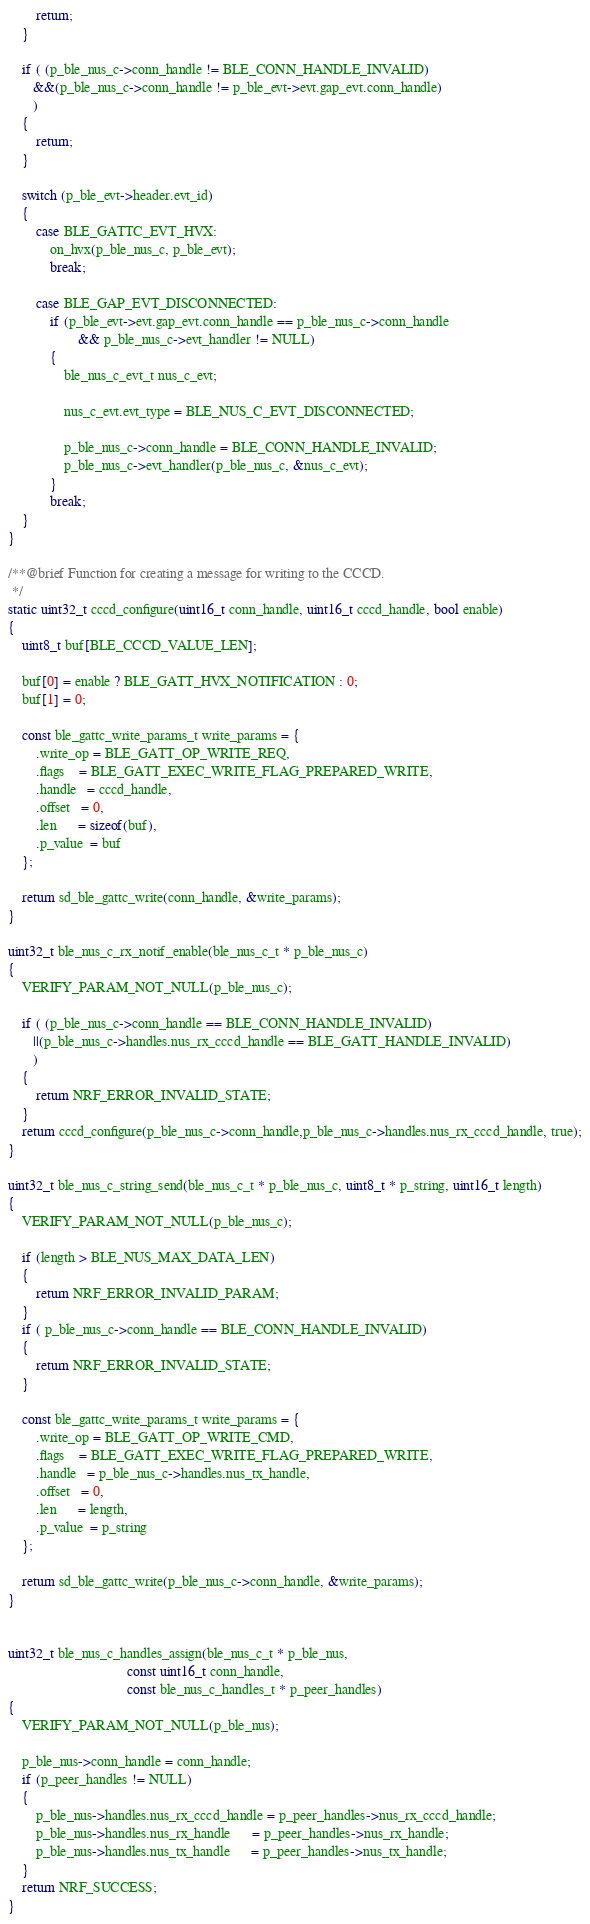<code> <loc_0><loc_0><loc_500><loc_500><_C_>        return;
    }

    if ( (p_ble_nus_c->conn_handle != BLE_CONN_HANDLE_INVALID) 
       &&(p_ble_nus_c->conn_handle != p_ble_evt->evt.gap_evt.conn_handle)
       )
    {
        return;
    }

    switch (p_ble_evt->header.evt_id)
    {
        case BLE_GATTC_EVT_HVX:
            on_hvx(p_ble_nus_c, p_ble_evt);
            break;
                
        case BLE_GAP_EVT_DISCONNECTED:
            if (p_ble_evt->evt.gap_evt.conn_handle == p_ble_nus_c->conn_handle
                    && p_ble_nus_c->evt_handler != NULL)
            {
                ble_nus_c_evt_t nus_c_evt;
                
                nus_c_evt.evt_type = BLE_NUS_C_EVT_DISCONNECTED;
                
                p_ble_nus_c->conn_handle = BLE_CONN_HANDLE_INVALID;
                p_ble_nus_c->evt_handler(p_ble_nus_c, &nus_c_evt);
            }
            break;
    }
}

/**@brief Function for creating a message for writing to the CCCD.
 */
static uint32_t cccd_configure(uint16_t conn_handle, uint16_t cccd_handle, bool enable)
{
    uint8_t buf[BLE_CCCD_VALUE_LEN];
    
    buf[0] = enable ? BLE_GATT_HVX_NOTIFICATION : 0;
    buf[1] = 0;
    
    const ble_gattc_write_params_t write_params = {
        .write_op = BLE_GATT_OP_WRITE_REQ,
        .flags    = BLE_GATT_EXEC_WRITE_FLAG_PREPARED_WRITE,
        .handle   = cccd_handle,
        .offset   = 0,
        .len      = sizeof(buf),
        .p_value  = buf
    };

    return sd_ble_gattc_write(conn_handle, &write_params);
}

uint32_t ble_nus_c_rx_notif_enable(ble_nus_c_t * p_ble_nus_c)
{
    VERIFY_PARAM_NOT_NULL(p_ble_nus_c);

    if ( (p_ble_nus_c->conn_handle == BLE_CONN_HANDLE_INVALID)
       ||(p_ble_nus_c->handles.nus_rx_cccd_handle == BLE_GATT_HANDLE_INVALID)
       )
    {
        return NRF_ERROR_INVALID_STATE;
    }
    return cccd_configure(p_ble_nus_c->conn_handle,p_ble_nus_c->handles.nus_rx_cccd_handle, true);
}

uint32_t ble_nus_c_string_send(ble_nus_c_t * p_ble_nus_c, uint8_t * p_string, uint16_t length)
{
    VERIFY_PARAM_NOT_NULL(p_ble_nus_c);
    
    if (length > BLE_NUS_MAX_DATA_LEN)
    {
        return NRF_ERROR_INVALID_PARAM;
    }
    if ( p_ble_nus_c->conn_handle == BLE_CONN_HANDLE_INVALID)
    {
        return NRF_ERROR_INVALID_STATE;
    }
    
    const ble_gattc_write_params_t write_params = {
        .write_op = BLE_GATT_OP_WRITE_CMD,
        .flags    = BLE_GATT_EXEC_WRITE_FLAG_PREPARED_WRITE,
        .handle   = p_ble_nus_c->handles.nus_tx_handle,
        .offset   = 0,
        .len      = length,
        .p_value  = p_string
    };

    return sd_ble_gattc_write(p_ble_nus_c->conn_handle, &write_params);
}


uint32_t ble_nus_c_handles_assign(ble_nus_c_t * p_ble_nus,
                                  const uint16_t conn_handle,
                                  const ble_nus_c_handles_t * p_peer_handles)
{
    VERIFY_PARAM_NOT_NULL(p_ble_nus);

    p_ble_nus->conn_handle = conn_handle;
    if (p_peer_handles != NULL)
    {
        p_ble_nus->handles.nus_rx_cccd_handle = p_peer_handles->nus_rx_cccd_handle;
        p_ble_nus->handles.nus_rx_handle      = p_peer_handles->nus_rx_handle;
        p_ble_nus->handles.nus_tx_handle      = p_peer_handles->nus_tx_handle;    
    }
    return NRF_SUCCESS;
}
</code> 